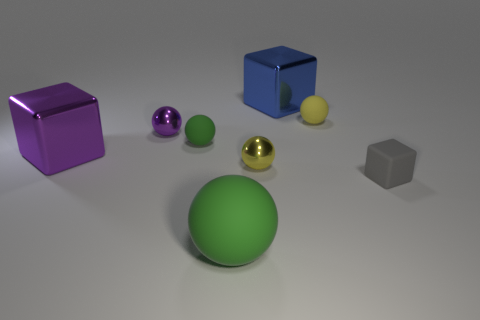Is there any other thing that has the same shape as the tiny yellow metallic object?
Provide a short and direct response. Yes. Is the number of large objects greater than the number of small yellow spheres?
Keep it short and to the point. Yes. What number of other things are the same material as the big purple object?
Offer a terse response. 3. The small object that is to the right of the tiny yellow sphere to the right of the large blue metal thing that is right of the small purple sphere is what shape?
Make the answer very short. Cube. Is the number of blocks that are behind the tiny matte block less than the number of rubber spheres that are behind the large matte sphere?
Make the answer very short. No. Are there any tiny rubber spheres of the same color as the big matte ball?
Provide a short and direct response. Yes. Is the material of the small green thing the same as the large object that is in front of the small gray object?
Offer a terse response. Yes. Is there a matte sphere to the right of the green thing behind the small gray rubber object?
Keep it short and to the point. Yes. What color is the block that is behind the small gray rubber thing and in front of the big blue shiny cube?
Offer a terse response. Purple. What is the size of the matte block?
Offer a terse response. Small. 